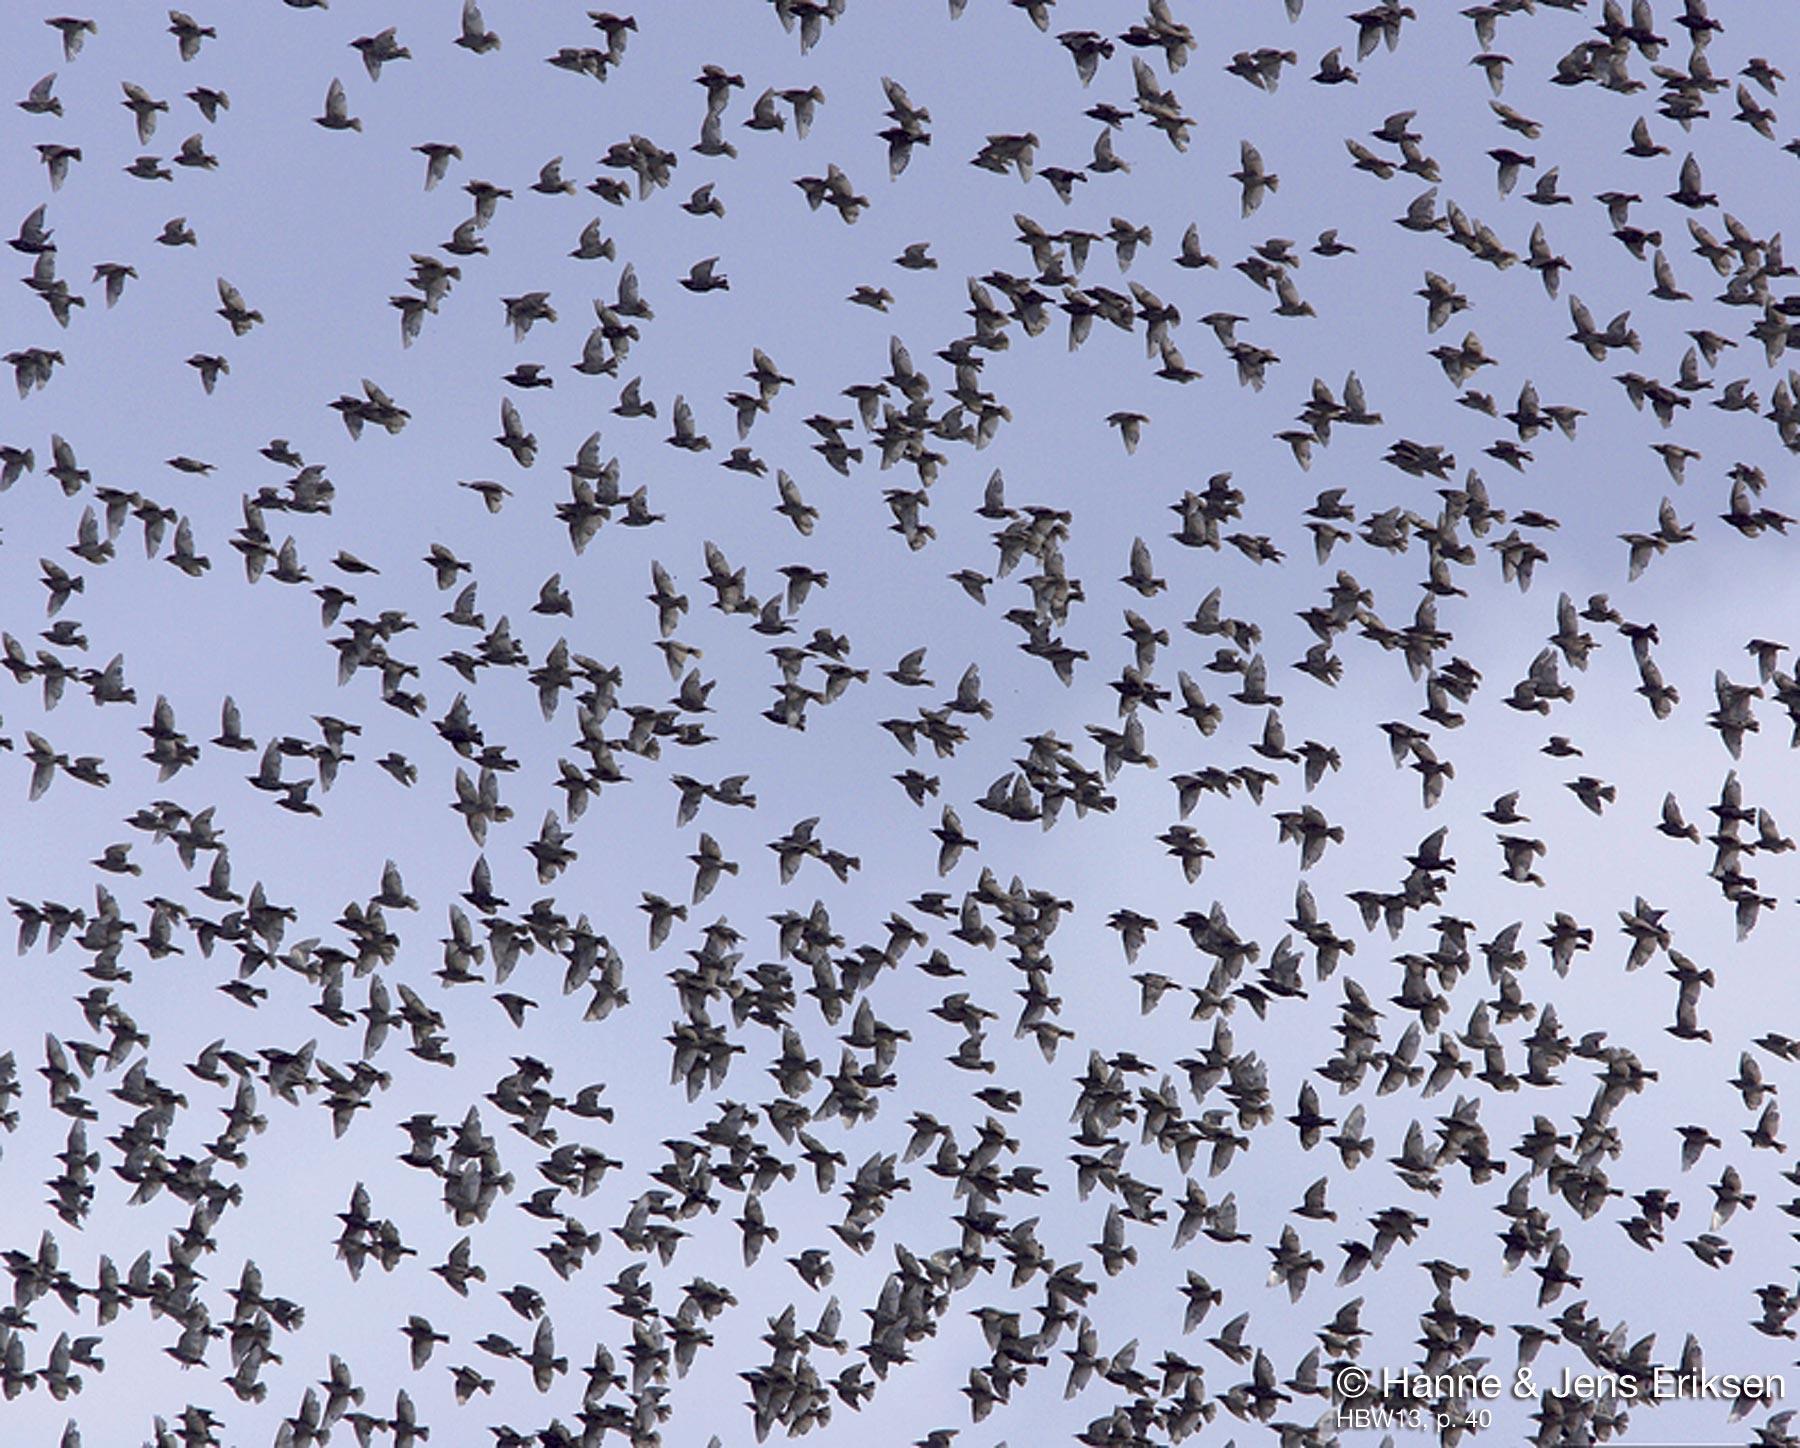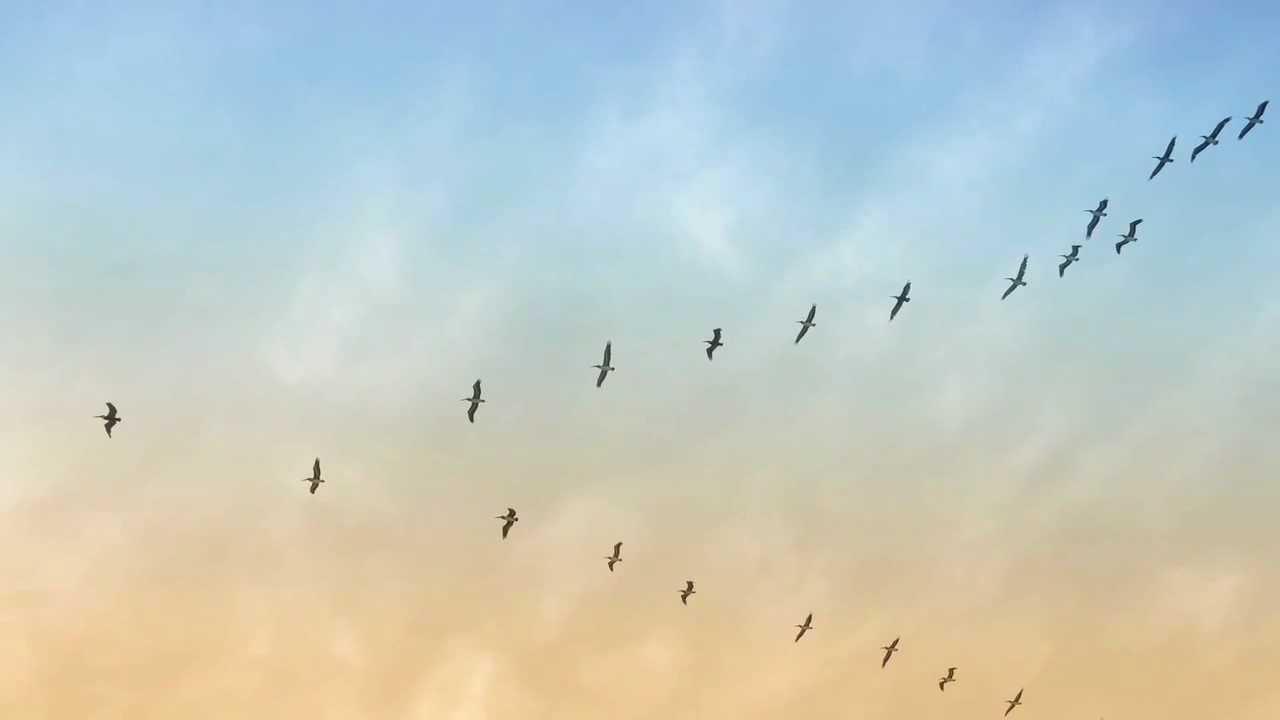The first image is the image on the left, the second image is the image on the right. Given the left and right images, does the statement "There are many more than 40 birds in total." hold true? Answer yes or no. Yes. The first image is the image on the left, the second image is the image on the right. Considering the images on both sides, is "The birds in the image on the right are flying in a v formation." valid? Answer yes or no. Yes. 